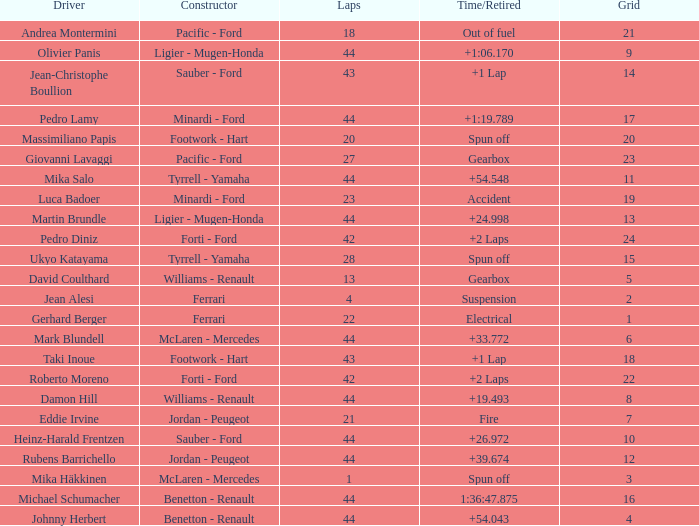I'm looking to parse the entire table for insights. Could you assist me with that? {'header': ['Driver', 'Constructor', 'Laps', 'Time/Retired', 'Grid'], 'rows': [['Andrea Montermini', 'Pacific - Ford', '18', 'Out of fuel', '21'], ['Olivier Panis', 'Ligier - Mugen-Honda', '44', '+1:06.170', '9'], ['Jean-Christophe Boullion', 'Sauber - Ford', '43', '+1 Lap', '14'], ['Pedro Lamy', 'Minardi - Ford', '44', '+1:19.789', '17'], ['Massimiliano Papis', 'Footwork - Hart', '20', 'Spun off', '20'], ['Giovanni Lavaggi', 'Pacific - Ford', '27', 'Gearbox', '23'], ['Mika Salo', 'Tyrrell - Yamaha', '44', '+54.548', '11'], ['Luca Badoer', 'Minardi - Ford', '23', 'Accident', '19'], ['Martin Brundle', 'Ligier - Mugen-Honda', '44', '+24.998', '13'], ['Pedro Diniz', 'Forti - Ford', '42', '+2 Laps', '24'], ['Ukyo Katayama', 'Tyrrell - Yamaha', '28', 'Spun off', '15'], ['David Coulthard', 'Williams - Renault', '13', 'Gearbox', '5'], ['Jean Alesi', 'Ferrari', '4', 'Suspension', '2'], ['Gerhard Berger', 'Ferrari', '22', 'Electrical', '1'], ['Mark Blundell', 'McLaren - Mercedes', '44', '+33.772', '6'], ['Taki Inoue', 'Footwork - Hart', '43', '+1 Lap', '18'], ['Roberto Moreno', 'Forti - Ford', '42', '+2 Laps', '22'], ['Damon Hill', 'Williams - Renault', '44', '+19.493', '8'], ['Eddie Irvine', 'Jordan - Peugeot', '21', 'Fire', '7'], ['Heinz-Harald Frentzen', 'Sauber - Ford', '44', '+26.972', '10'], ['Rubens Barrichello', 'Jordan - Peugeot', '44', '+39.674', '12'], ['Mika Häkkinen', 'McLaren - Mercedes', '1', 'Spun off', '3'], ['Michael Schumacher', 'Benetton - Renault', '44', '1:36:47.875', '16'], ['Johnny Herbert', 'Benetton - Renault', '44', '+54.043', '4']]} What is the high lap total for cards with a grid larger than 21, and a Time/Retired of +2 laps? 42.0. 